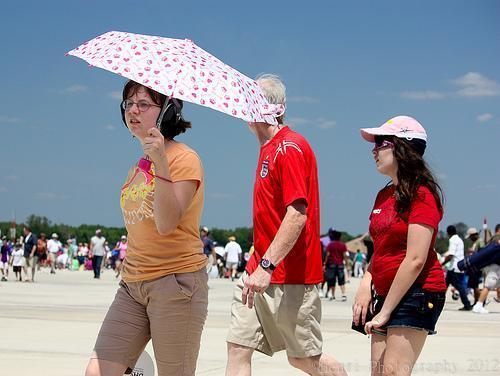How many people are wearing red shirts?
Give a very brief answer. 2. 